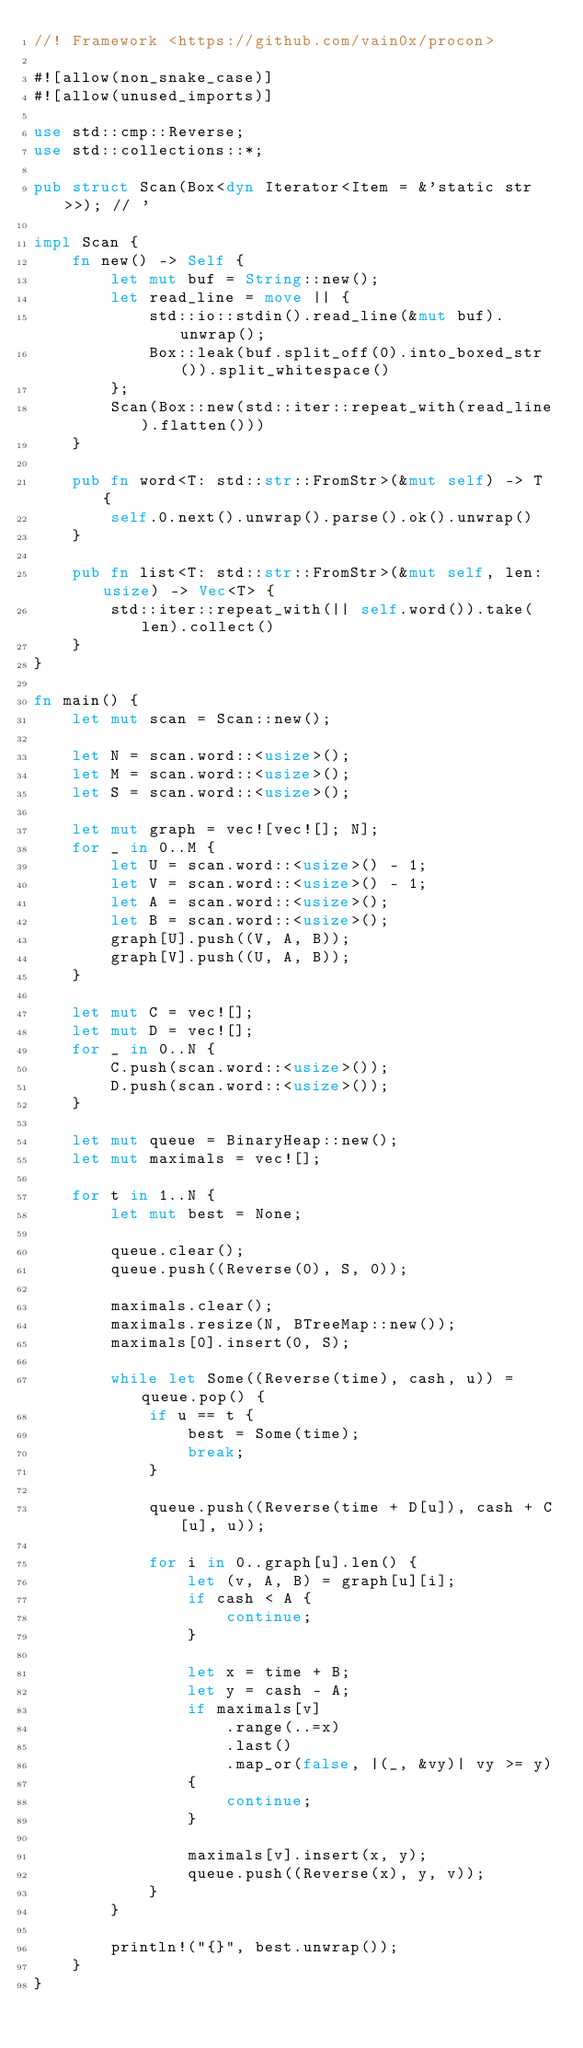<code> <loc_0><loc_0><loc_500><loc_500><_Rust_>//! Framework <https://github.com/vain0x/procon>

#![allow(non_snake_case)]
#![allow(unused_imports)]

use std::cmp::Reverse;
use std::collections::*;

pub struct Scan(Box<dyn Iterator<Item = &'static str>>); // '

impl Scan {
    fn new() -> Self {
        let mut buf = String::new();
        let read_line = move || {
            std::io::stdin().read_line(&mut buf).unwrap();
            Box::leak(buf.split_off(0).into_boxed_str()).split_whitespace()
        };
        Scan(Box::new(std::iter::repeat_with(read_line).flatten()))
    }

    pub fn word<T: std::str::FromStr>(&mut self) -> T {
        self.0.next().unwrap().parse().ok().unwrap()
    }

    pub fn list<T: std::str::FromStr>(&mut self, len: usize) -> Vec<T> {
        std::iter::repeat_with(|| self.word()).take(len).collect()
    }
}

fn main() {
    let mut scan = Scan::new();

    let N = scan.word::<usize>();
    let M = scan.word::<usize>();
    let S = scan.word::<usize>();

    let mut graph = vec![vec![]; N];
    for _ in 0..M {
        let U = scan.word::<usize>() - 1;
        let V = scan.word::<usize>() - 1;
        let A = scan.word::<usize>();
        let B = scan.word::<usize>();
        graph[U].push((V, A, B));
        graph[V].push((U, A, B));
    }

    let mut C = vec![];
    let mut D = vec![];
    for _ in 0..N {
        C.push(scan.word::<usize>());
        D.push(scan.word::<usize>());
    }

    let mut queue = BinaryHeap::new();
    let mut maximals = vec![];

    for t in 1..N {
        let mut best = None;

        queue.clear();
        queue.push((Reverse(0), S, 0));

        maximals.clear();
        maximals.resize(N, BTreeMap::new());
        maximals[0].insert(0, S);

        while let Some((Reverse(time), cash, u)) = queue.pop() {
            if u == t {
                best = Some(time);
                break;
            }

            queue.push((Reverse(time + D[u]), cash + C[u], u));

            for i in 0..graph[u].len() {
                let (v, A, B) = graph[u][i];
                if cash < A {
                    continue;
                }

                let x = time + B;
                let y = cash - A;
                if maximals[v]
                    .range(..=x)
                    .last()
                    .map_or(false, |(_, &vy)| vy >= y)
                {
                    continue;
                }

                maximals[v].insert(x, y);
                queue.push((Reverse(x), y, v));
            }
        }

        println!("{}", best.unwrap());
    }
}
</code> 